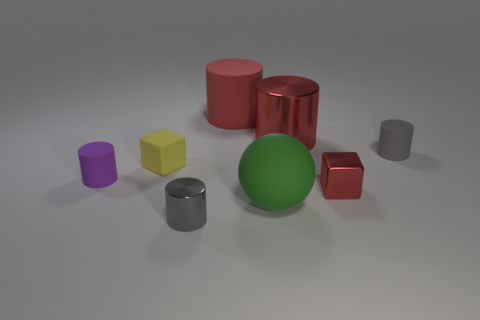Subtract all purple cylinders. How many cylinders are left? 4 Subtract all small purple cylinders. How many cylinders are left? 4 Subtract all blue cylinders. Subtract all blue spheres. How many cylinders are left? 5 Add 2 yellow cubes. How many objects exist? 10 Subtract all cubes. How many objects are left? 6 Subtract all tiny cyan things. Subtract all yellow things. How many objects are left? 7 Add 8 large red shiny objects. How many large red shiny objects are left? 9 Add 7 red matte things. How many red matte things exist? 8 Subtract 0 cyan cylinders. How many objects are left? 8 